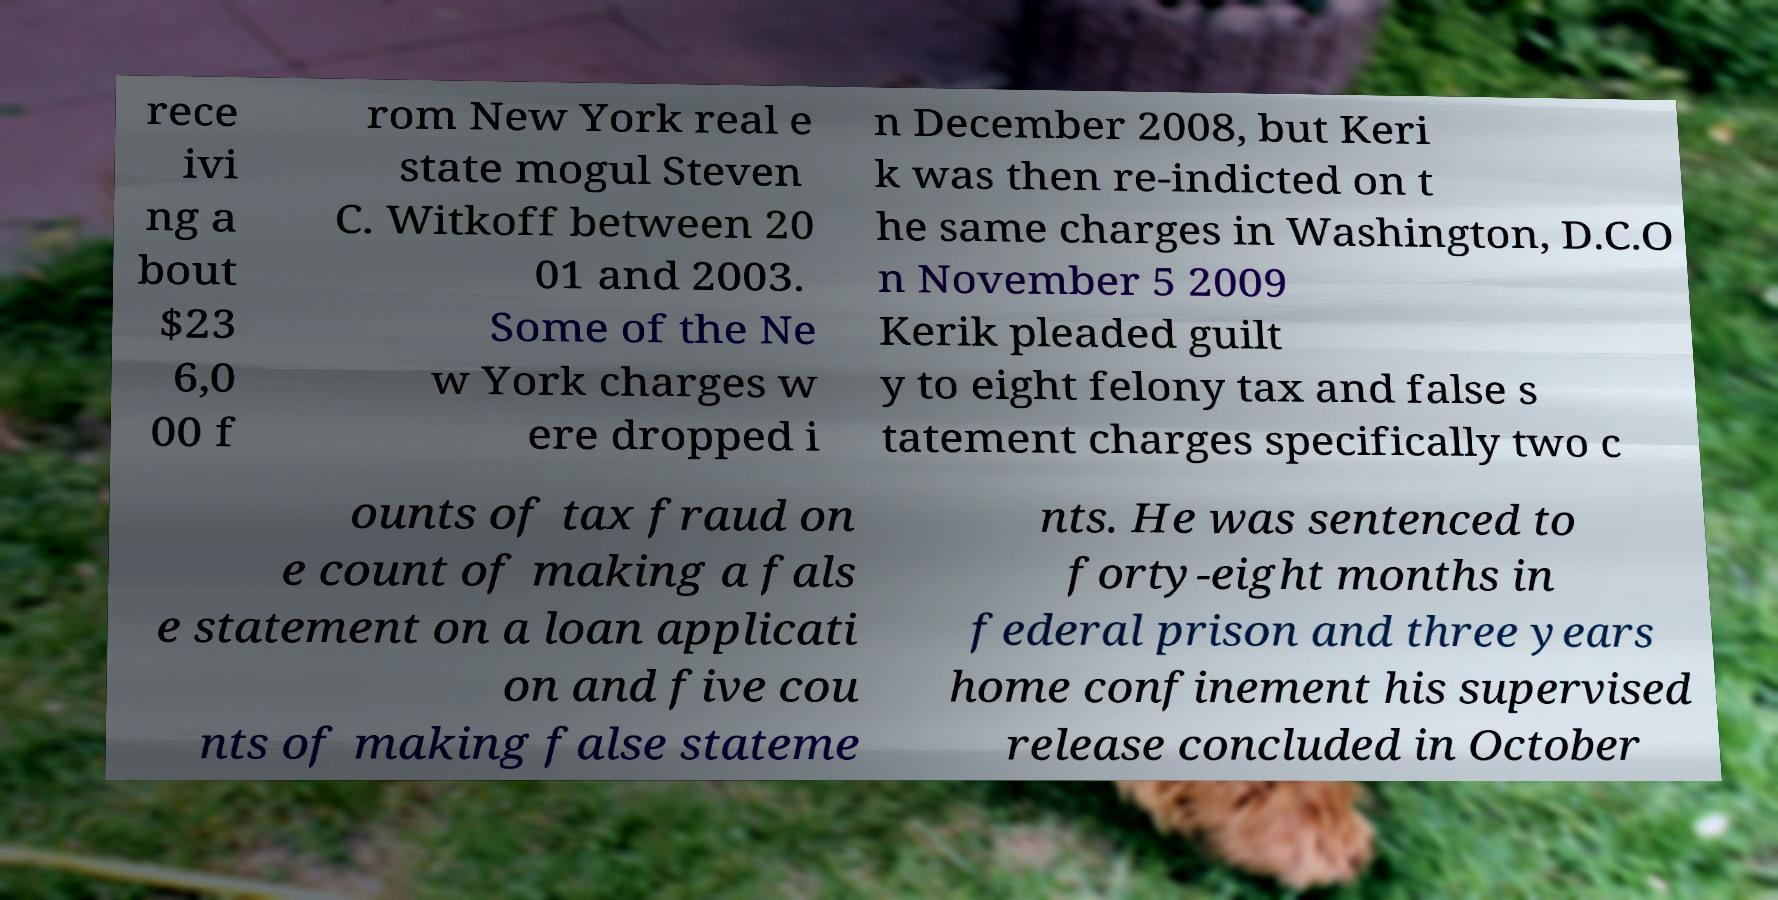There's text embedded in this image that I need extracted. Can you transcribe it verbatim? rece ivi ng a bout $23 6,0 00 f rom New York real e state mogul Steven C. Witkoff between 20 01 and 2003. Some of the Ne w York charges w ere dropped i n December 2008, but Keri k was then re-indicted on t he same charges in Washington, D.C.O n November 5 2009 Kerik pleaded guilt y to eight felony tax and false s tatement charges specifically two c ounts of tax fraud on e count of making a fals e statement on a loan applicati on and five cou nts of making false stateme nts. He was sentenced to forty-eight months in federal prison and three years home confinement his supervised release concluded in October 